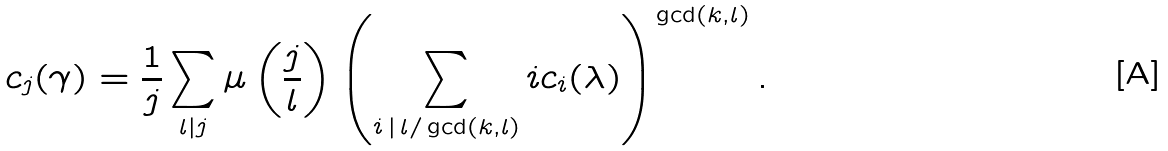Convert formula to latex. <formula><loc_0><loc_0><loc_500><loc_500>c _ { j } ( \gamma ) = \frac { 1 } { j } \sum _ { l | j } \mu \left ( \frac { j } { l } \right ) \left ( \sum _ { i \, | \, l / \gcd ( k , l ) } i c _ { i } ( \lambda ) \right ) ^ { \gcd ( k , l ) } .</formula> 